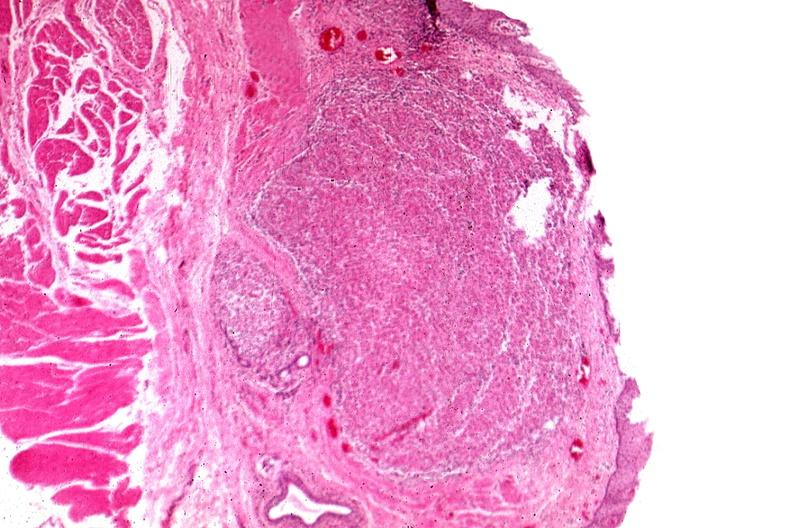s leg present?
Answer the question using a single word or phrase. No 